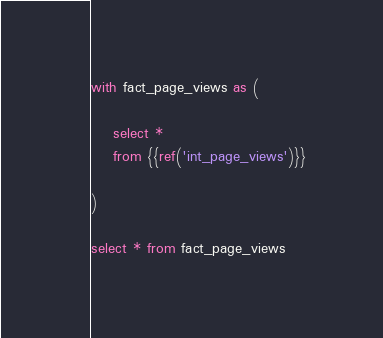<code> <loc_0><loc_0><loc_500><loc_500><_SQL_>with fact_page_views as (

    select *
    from {{ref('int_page_views')}}
    
)

select * from fact_page_views</code> 